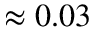Convert formula to latex. <formula><loc_0><loc_0><loc_500><loc_500>\approx 0 . 0 3</formula> 